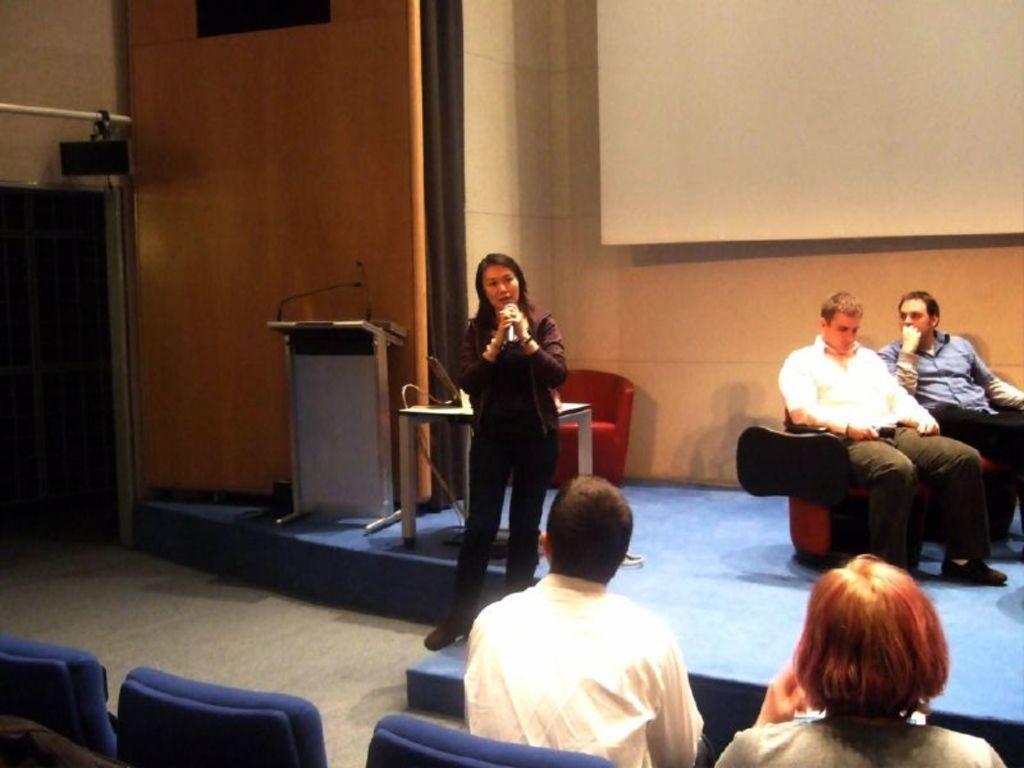Describe this image in one or two sentences. This picture is taken in a room. In the center, there is a woman holding a mike. Before her, there is a man and a woman sitting on chairs. Towards the right, there are two men sitting on sofas. One men is wearing cream shirt and another man is wearing blue shirt. In the center, there is a podium, table and a sofa on the stage. On the top, there is a wall with a screen. 